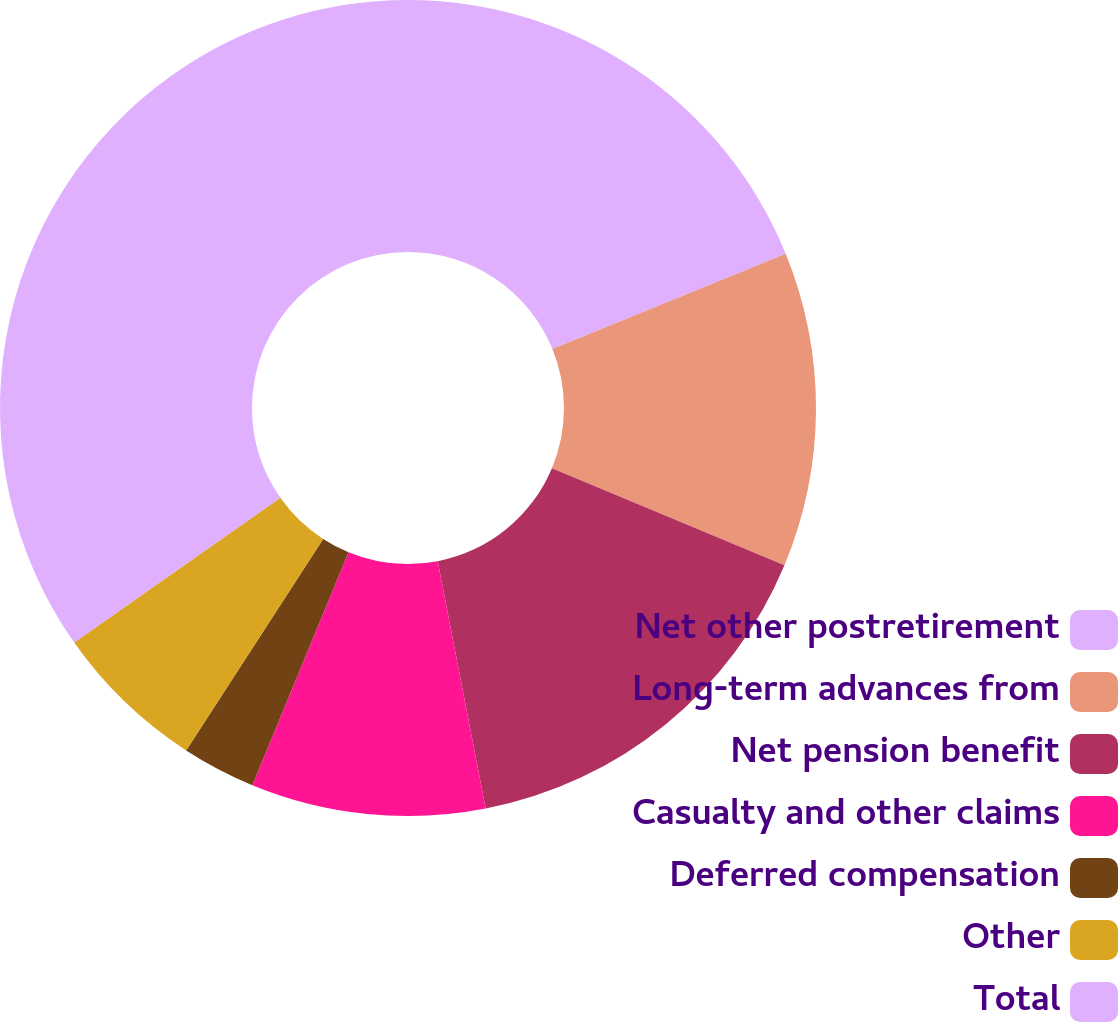Convert chart. <chart><loc_0><loc_0><loc_500><loc_500><pie_chart><fcel>Net other postretirement<fcel>Long-term advances from<fcel>Net pension benefit<fcel>Casualty and other claims<fcel>Deferred compensation<fcel>Other<fcel>Total<nl><fcel>18.83%<fcel>12.47%<fcel>15.65%<fcel>9.28%<fcel>2.92%<fcel>6.1%<fcel>34.75%<nl></chart> 